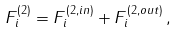Convert formula to latex. <formula><loc_0><loc_0><loc_500><loc_500>F _ { i } ^ { ( 2 ) } = F _ { i } ^ { ( 2 , i n ) } + F _ { i } ^ { ( 2 , o u t ) } \, ,</formula> 